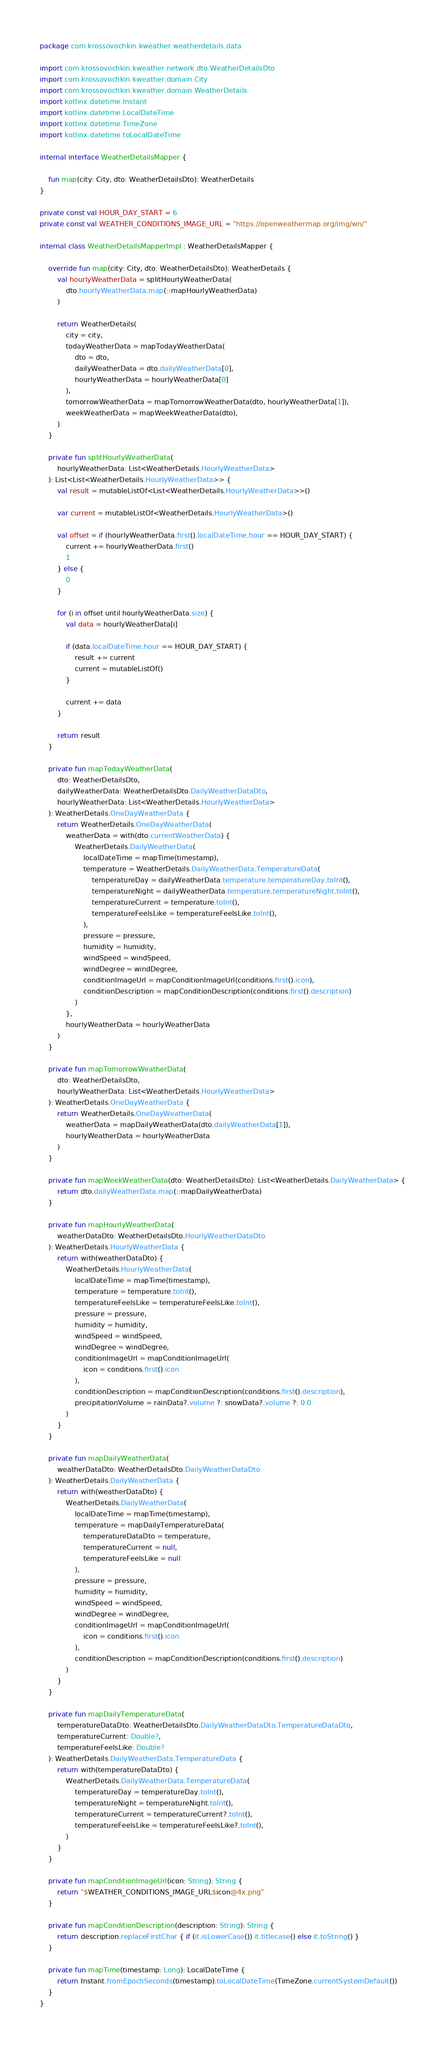<code> <loc_0><loc_0><loc_500><loc_500><_Kotlin_>package com.krossovochkin.kweather.weatherdetails.data

import com.krossovochkin.kweather.network.dto.WeatherDetailsDto
import com.krossovochkin.kweather.domain.City
import com.krossovochkin.kweather.domain.WeatherDetails
import kotlinx.datetime.Instant
import kotlinx.datetime.LocalDateTime
import kotlinx.datetime.TimeZone
import kotlinx.datetime.toLocalDateTime

internal interface WeatherDetailsMapper {

    fun map(city: City, dto: WeatherDetailsDto): WeatherDetails
}

private const val HOUR_DAY_START = 6
private const val WEATHER_CONDITIONS_IMAGE_URL = "https://openweathermap.org/img/wn/"

internal class WeatherDetailsMapperImpl : WeatherDetailsMapper {

    override fun map(city: City, dto: WeatherDetailsDto): WeatherDetails {
        val hourlyWeatherData = splitHourlyWeatherData(
            dto.hourlyWeatherData.map(::mapHourlyWeatherData)
        )

        return WeatherDetails(
            city = city,
            todayWeatherData = mapTodayWeatherData(
                dto = dto,
                dailyWeatherData = dto.dailyWeatherData[0],
                hourlyWeatherData = hourlyWeatherData[0]
            ),
            tomorrowWeatherData = mapTomorrowWeatherData(dto, hourlyWeatherData[1]),
            weekWeatherData = mapWeekWeatherData(dto),
        )
    }

    private fun splitHourlyWeatherData(
        hourlyWeatherData: List<WeatherDetails.HourlyWeatherData>
    ): List<List<WeatherDetails.HourlyWeatherData>> {
        val result = mutableListOf<List<WeatherDetails.HourlyWeatherData>>()

        var current = mutableListOf<WeatherDetails.HourlyWeatherData>()

        val offset = if (hourlyWeatherData.first().localDateTime.hour == HOUR_DAY_START) {
            current += hourlyWeatherData.first()
            1
        } else {
            0
        }

        for (i in offset until hourlyWeatherData.size) {
            val data = hourlyWeatherData[i]

            if (data.localDateTime.hour == HOUR_DAY_START) {
                result += current
                current = mutableListOf()
            }

            current += data
        }

        return result
    }

    private fun mapTodayWeatherData(
        dto: WeatherDetailsDto,
        dailyWeatherData: WeatherDetailsDto.DailyWeatherDataDto,
        hourlyWeatherData: List<WeatherDetails.HourlyWeatherData>
    ): WeatherDetails.OneDayWeatherData {
        return WeatherDetails.OneDayWeatherData(
            weatherData = with(dto.currentWeatherData) {
                WeatherDetails.DailyWeatherData(
                    localDateTime = mapTime(timestamp),
                    temperature = WeatherDetails.DailyWeatherData.TemperatureData(
                        temperatureDay = dailyWeatherData.temperature.temperatureDay.toInt(),
                        temperatureNight = dailyWeatherData.temperature.temperatureNight.toInt(),
                        temperatureCurrent = temperature.toInt(),
                        temperatureFeelsLike = temperatureFeelsLike.toInt(),
                    ),
                    pressure = pressure,
                    humidity = humidity,
                    windSpeed = windSpeed,
                    windDegree = windDegree,
                    conditionImageUrl = mapConditionImageUrl(conditions.first().icon),
                    conditionDescription = mapConditionDescription(conditions.first().description)
                )
            },
            hourlyWeatherData = hourlyWeatherData
        )
    }

    private fun mapTomorrowWeatherData(
        dto: WeatherDetailsDto,
        hourlyWeatherData: List<WeatherDetails.HourlyWeatherData>
    ): WeatherDetails.OneDayWeatherData {
        return WeatherDetails.OneDayWeatherData(
            weatherData = mapDailyWeatherData(dto.dailyWeatherData[1]),
            hourlyWeatherData = hourlyWeatherData
        )
    }

    private fun mapWeekWeatherData(dto: WeatherDetailsDto): List<WeatherDetails.DailyWeatherData> {
        return dto.dailyWeatherData.map(::mapDailyWeatherData)
    }

    private fun mapHourlyWeatherData(
        weatherDataDto: WeatherDetailsDto.HourlyWeatherDataDto
    ): WeatherDetails.HourlyWeatherData {
        return with(weatherDataDto) {
            WeatherDetails.HourlyWeatherData(
                localDateTime = mapTime(timestamp),
                temperature = temperature.toInt(),
                temperatureFeelsLike = temperatureFeelsLike.toInt(),
                pressure = pressure,
                humidity = humidity,
                windSpeed = windSpeed,
                windDegree = windDegree,
                conditionImageUrl = mapConditionImageUrl(
                    icon = conditions.first().icon
                ),
                conditionDescription = mapConditionDescription(conditions.first().description),
                precipitationVolume = rainData?.volume ?: snowData?.volume ?: 0.0
            )
        }
    }

    private fun mapDailyWeatherData(
        weatherDataDto: WeatherDetailsDto.DailyWeatherDataDto
    ): WeatherDetails.DailyWeatherData {
        return with(weatherDataDto) {
            WeatherDetails.DailyWeatherData(
                localDateTime = mapTime(timestamp),
                temperature = mapDailyTemperatureData(
                    temperatureDataDto = temperature,
                    temperatureCurrent = null,
                    temperatureFeelsLike = null
                ),
                pressure = pressure,
                humidity = humidity,
                windSpeed = windSpeed,
                windDegree = windDegree,
                conditionImageUrl = mapConditionImageUrl(
                    icon = conditions.first().icon
                ),
                conditionDescription = mapConditionDescription(conditions.first().description)
            )
        }
    }

    private fun mapDailyTemperatureData(
        temperatureDataDto: WeatherDetailsDto.DailyWeatherDataDto.TemperatureDataDto,
        temperatureCurrent: Double?,
        temperatureFeelsLike: Double?
    ): WeatherDetails.DailyWeatherData.TemperatureData {
        return with(temperatureDataDto) {
            WeatherDetails.DailyWeatherData.TemperatureData(
                temperatureDay = temperatureDay.toInt(),
                temperatureNight = temperatureNight.toInt(),
                temperatureCurrent = temperatureCurrent?.toInt(),
                temperatureFeelsLike = temperatureFeelsLike?.toInt(),
            )
        }
    }

    private fun mapConditionImageUrl(icon: String): String {
        return "$WEATHER_CONDITIONS_IMAGE_URL$icon@4x.png"
    }

    private fun mapConditionDescription(description: String): String {
        return description.replaceFirstChar { if (it.isLowerCase()) it.titlecase() else it.toString() }
    }

    private fun mapTime(timestamp: Long): LocalDateTime {
        return Instant.fromEpochSeconds(timestamp).toLocalDateTime(TimeZone.currentSystemDefault())
    }
}
</code> 